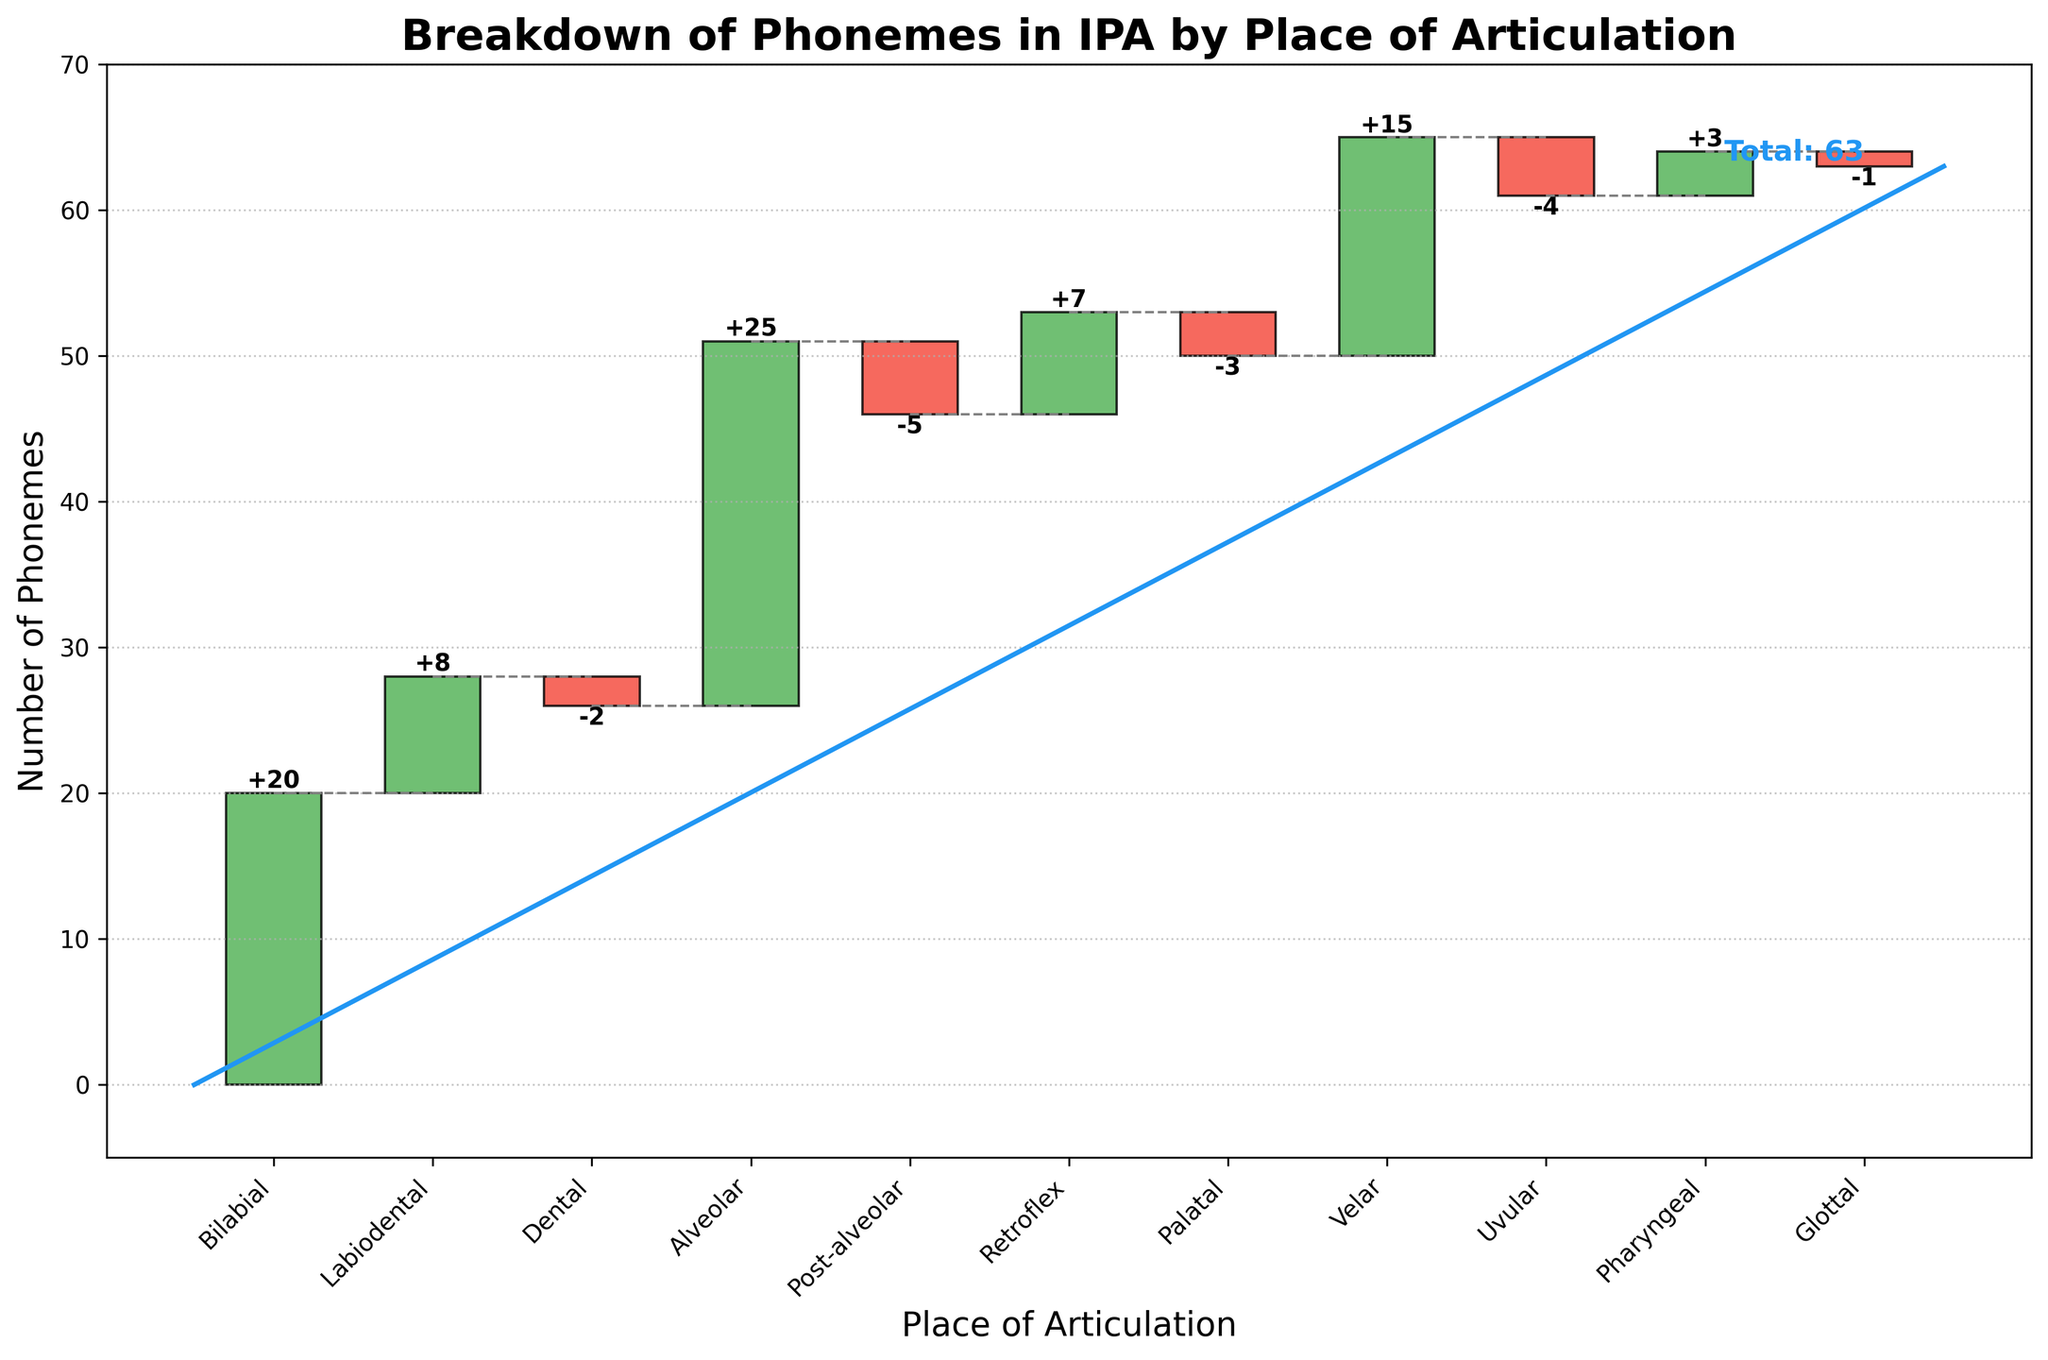What's the total number of phonemes represented in the chart? The total number of phonemes is indicated by the "Total" value at the end of the chart, which is 63.
Answer: 63 Which category contributes the most phonemes? The category contributing the most phonemes is the one with the highest bar. From the chart, the "Alveolar" category has the highest value at 25 phonemes.
Answer: Alveolar Which category reduces the total phonemes the most? The category with the most significant negative value has the largest reduction. "Post-alveolar" has a value of -5, which is the most considerable reduction in the chart.
Answer: Post-alveolar What's the cumulative total after the "Velar" category? The cumulative total is calculated by summing all the values up to and including "Velar." This sum is 20 (Bilabial) + 8 (Labiodental) - 2 (Dental) + 25 (Alveolar) - 5 (Post-alveolar) + 7 (Retroflex) - 3 (Palatal) + 15 (Velar) = 65.
Answer: 65 How many categories have a negative value? By observing the bars with downward direction (negative values), there are four categories: "Dental," "Post-alveolar," "Palatal," and "Uvular."
Answer: 4 What's the net phoneme count difference between "Retroflex" and "Palatal"? "Retroflex" has a value of 7 and "Palatal" has a value of -3. The difference is 7 - (-3) = 10.
Answer: 10 Which category is closest in phoneme count to the "Glottal" category? "Glottal" has a value of -1. Observing the chart, the "Palatal" category is also close with a value of -3.
Answer: Palatal What is the cumulative phoneme count after the first five categories? Add the phonemes from the first five categories: 20 (Bilabial) + 8 (Labiodental) - 2 (Dental) + 25 (Alveolar) - 5 (Post-alveolar) = 46.
Answer: 46 How does the "Bilabial" category's phoneme count compare to the "Uvular" category's? "Bilabial" has 20 phonemes and "Uvular" has -4 phonemes. "Bilabial" has more phonemes than "Uvular."
Answer: Bilabial has more What are the total positive contributions to the phoneme count? Sum all positive values: 20 (Bilabial) + 8 (Labiodental) + 25 (Alveolar) + 7 (Retroflex) + 15 (Velar) + 3 (Pharyngeal) = 78.
Answer: 78 